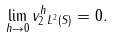<formula> <loc_0><loc_0><loc_500><loc_500>\lim _ { h \to 0 } \| v _ { 2 } ^ { h } \| _ { L ^ { 2 } ( S ) } = 0 .</formula> 